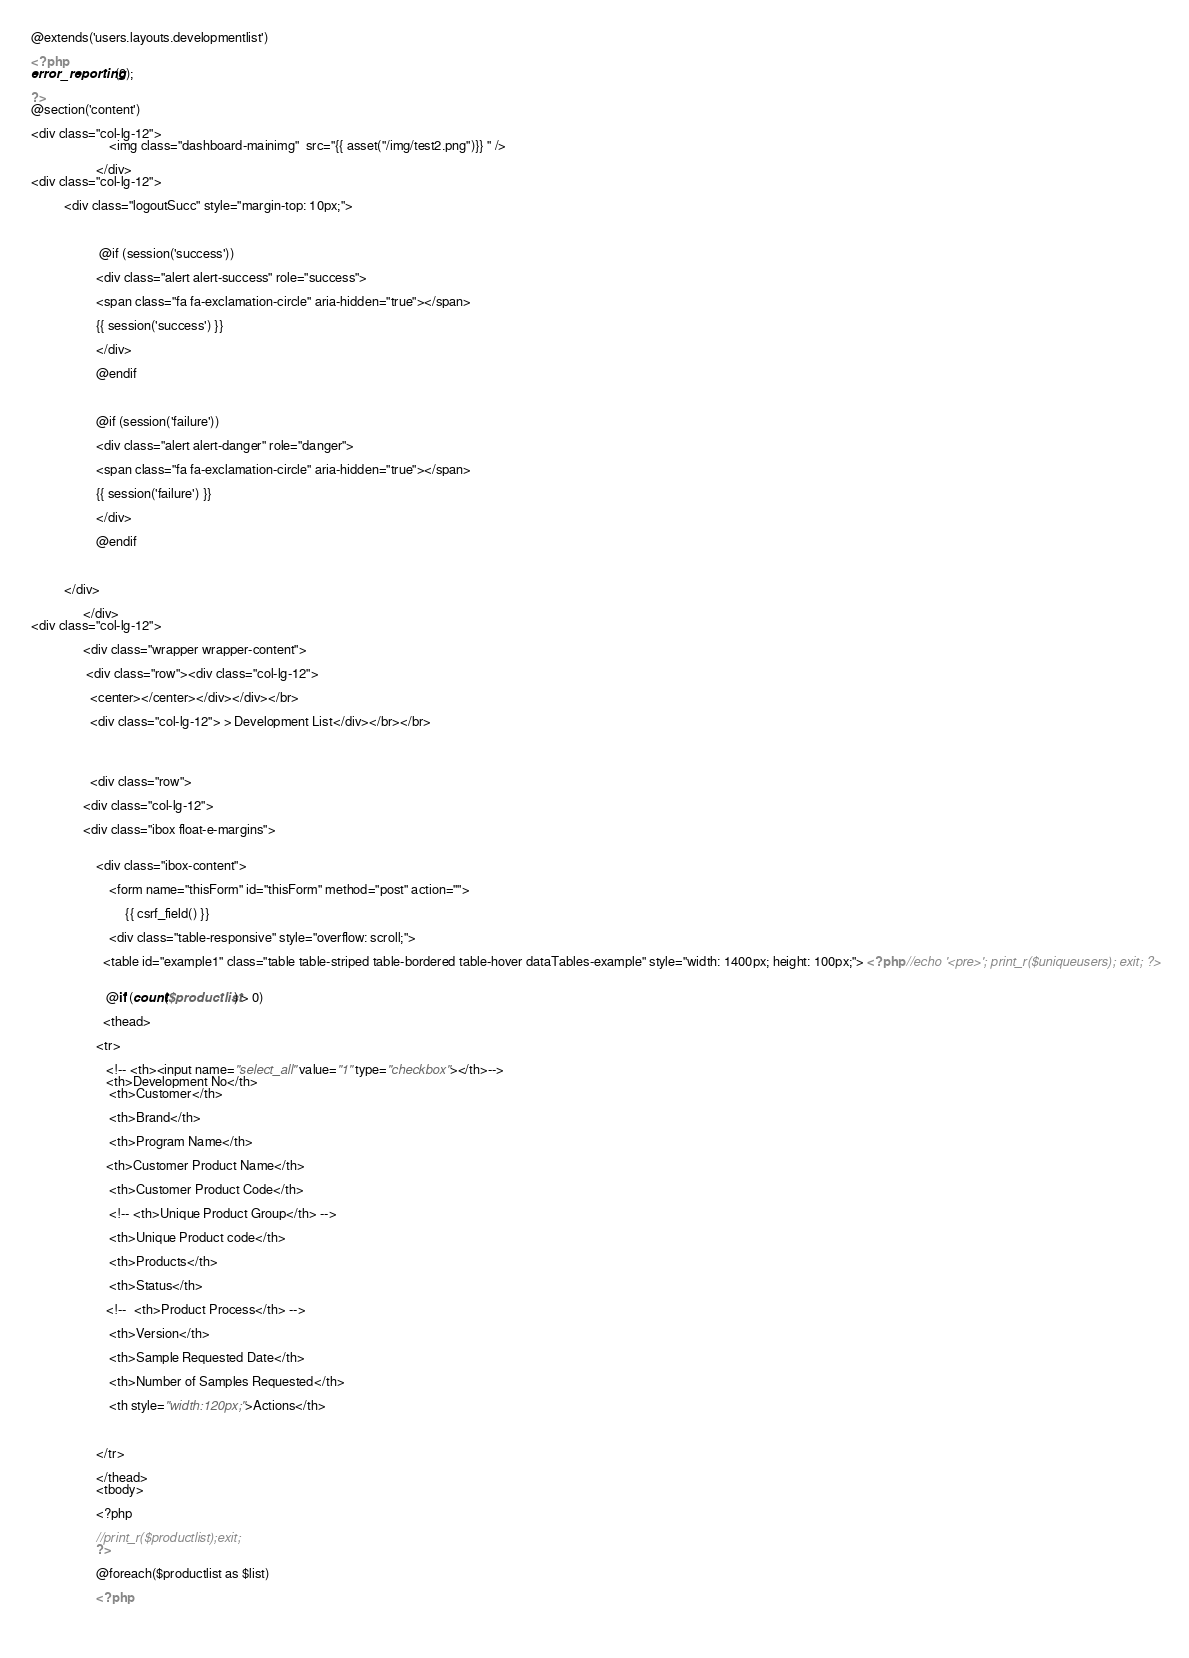<code> <loc_0><loc_0><loc_500><loc_500><_PHP_>@extends('users.layouts.developmentlist')

<?php
error_reporting(0);

?>
@section('content')

<div class="col-lg-12">
                        <img class="dashboard-mainimg"  src="{{ asset("/img/test2.png")}} " />
                        
                    </div>
<div class="col-lg-12">

          <div class="logoutSucc" style="margin-top: 10px;">



                     @if (session('success'))

                    <div class="alert alert-success" role="success">

                    <span class="fa fa-exclamation-circle" aria-hidden="true"></span>

                    {{ session('success') }}

                    </div>

                    @endif



                    @if (session('failure'))

                    <div class="alert alert-danger" role="danger">

                    <span class="fa fa-exclamation-circle" aria-hidden="true"></span>

                    {{ session('failure') }}

                    </div>

                    @endif



          </div>

                </div>
<div class="col-lg-12">
            
                <div class="wrapper wrapper-content">
                
                 <div class="row"><div class="col-lg-12">

                  <center></center></div></div></br>

                  <div class="col-lg-12"> > Development List</div></br></br>

                                   


                  <div class="row">

                <div class="col-lg-12">

                <div class="ibox float-e-margins">

                    
                    <div class="ibox-content">

                        <form name="thisForm" id="thisForm" method="post" action="">

                             {{ csrf_field() }}

                        <div class="table-responsive" style="overflow: scroll;">

                      <table id="example1" class="table table-striped table-bordered table-hover dataTables-example" style="width: 1400px; height: 100px;"> <?php //echo '<pre>'; print_r($uniqueusers); exit; ?>

                     
                       @if (count($productlist) > 0)

                      <thead>

                    <tr>

                       <!-- <th><input name="select_all" value="1" type="checkbox"></th>-->
                       <th>Development No</th>
                        <th>Customer</th>

                        <th>Brand</th> 

                        <th>Program Name</th>  

                       <th>Customer Product Name</th>                                    

                        <th>Customer Product Code</th>

                        <!-- <th>Unique Product Group</th> -->

                        <th>Unique Product code</th>

                        <th>Products</th>

                        <th>Status</th>

                       <!--  <th>Product Process</th> -->

                        <th>Version</th>

                        <th>Sample Requested Date</th>

                        <th>Number of Samples Requested</th>

                        <th style="width:120px;">Actions</th>

                        

                    </tr>

                    </thead>
                    <tbody>

                    <?php
					
					//print_r($productlist);exit;
					?>

                    @foreach($productlist as $list)                        

                    <?php 

                  </code> 